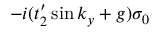<formula> <loc_0><loc_0><loc_500><loc_500>- i ( t _ { 2 } ^ { \prime } \sin k _ { y } + g ) \sigma _ { 0 }</formula> 